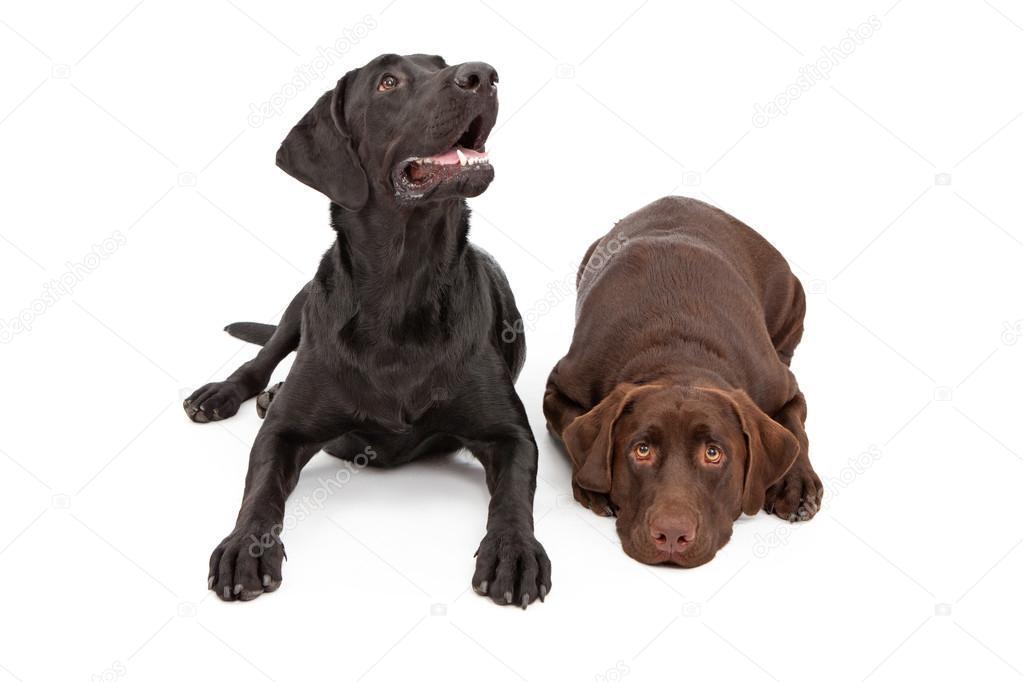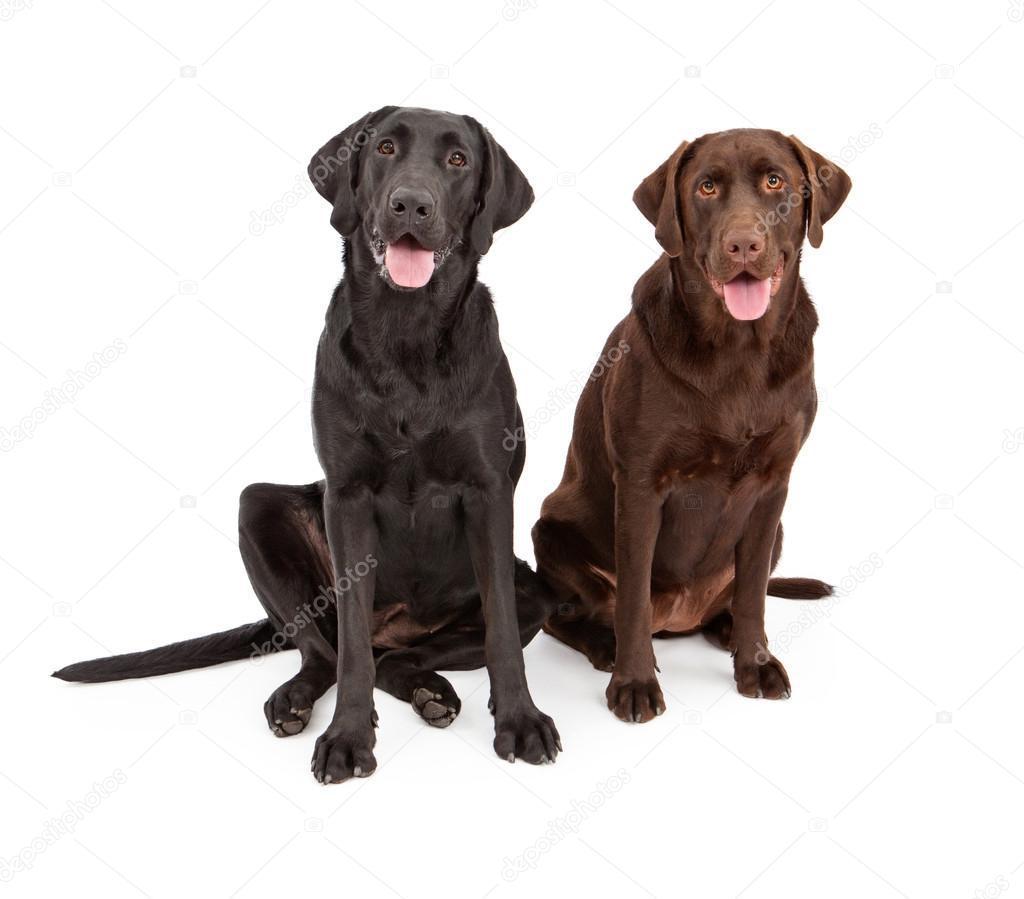The first image is the image on the left, the second image is the image on the right. Evaluate the accuracy of this statement regarding the images: "At least one dog has its tongue out.". Is it true? Answer yes or no. Yes. The first image is the image on the left, the second image is the image on the right. Analyze the images presented: Is the assertion "One image shows a single black dog and the other shows a pair of brown dogs." valid? Answer yes or no. No. 